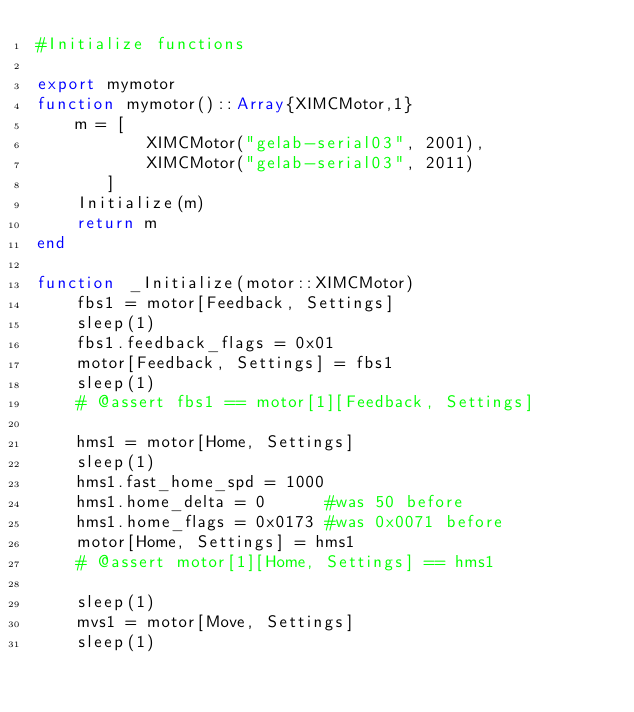<code> <loc_0><loc_0><loc_500><loc_500><_Julia_>#Initialize functions

export mymotor
function mymotor()::Array{XIMCMotor,1}
	m = [
           XIMCMotor("gelab-serial03", 2001),
           XIMCMotor("gelab-serial03", 2011)
       ]
	Initialize(m)
	return m
end

function _Initialize(motor::XIMCMotor)
	fbs1 = motor[Feedback, Settings]
	sleep(1)
	fbs1.feedback_flags = 0x01
	motor[Feedback, Settings] = fbs1
	sleep(1)
	# @assert fbs1 == motor[1][Feedback, Settings]

	hms1 = motor[Home, Settings]
	sleep(1)
	hms1.fast_home_spd = 1000
	hms1.home_delta = 0	 	 #was 50 before
	hms1.home_flags = 0x0173 #was 0x0071 before
	motor[Home, Settings] = hms1
	# @assert motor[1][Home, Settings] == hms1

	sleep(1)
	mvs1 = motor[Move, Settings]
	sleep(1)</code> 